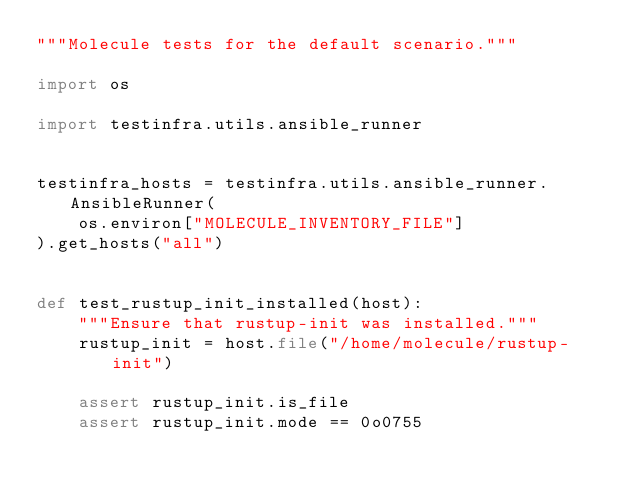Convert code to text. <code><loc_0><loc_0><loc_500><loc_500><_Python_>"""Molecule tests for the default scenario."""

import os

import testinfra.utils.ansible_runner


testinfra_hosts = testinfra.utils.ansible_runner.AnsibleRunner(
    os.environ["MOLECULE_INVENTORY_FILE"]
).get_hosts("all")


def test_rustup_init_installed(host):
    """Ensure that rustup-init was installed."""
    rustup_init = host.file("/home/molecule/rustup-init")

    assert rustup_init.is_file
    assert rustup_init.mode == 0o0755
</code> 